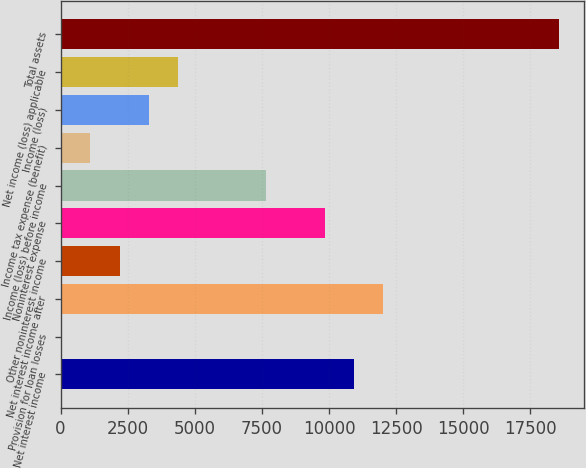Convert chart to OTSL. <chart><loc_0><loc_0><loc_500><loc_500><bar_chart><fcel>Net interest income<fcel>Provision for loan losses<fcel>Net interest income after<fcel>Other noninterest income<fcel>Noninterest expense<fcel>Income (loss) before income<fcel>Income tax expense (benefit)<fcel>Income (loss)<fcel>Net income (loss) applicable<fcel>Total assets<nl><fcel>10923<fcel>16.7<fcel>12013.6<fcel>2197.96<fcel>9832.37<fcel>7651.11<fcel>1107.33<fcel>3288.59<fcel>4379.22<fcel>18557.4<nl></chart> 